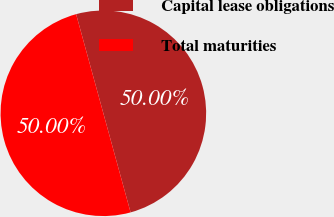<chart> <loc_0><loc_0><loc_500><loc_500><pie_chart><fcel>Capital lease obligations<fcel>Total maturities<nl><fcel>50.0%<fcel>50.0%<nl></chart> 